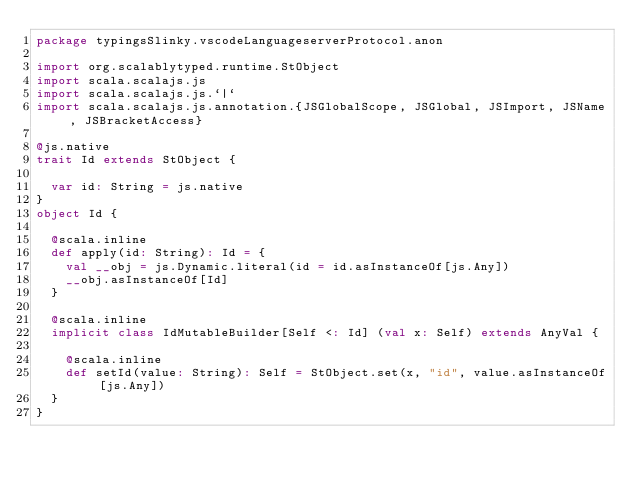<code> <loc_0><loc_0><loc_500><loc_500><_Scala_>package typingsSlinky.vscodeLanguageserverProtocol.anon

import org.scalablytyped.runtime.StObject
import scala.scalajs.js
import scala.scalajs.js.`|`
import scala.scalajs.js.annotation.{JSGlobalScope, JSGlobal, JSImport, JSName, JSBracketAccess}

@js.native
trait Id extends StObject {
  
  var id: String = js.native
}
object Id {
  
  @scala.inline
  def apply(id: String): Id = {
    val __obj = js.Dynamic.literal(id = id.asInstanceOf[js.Any])
    __obj.asInstanceOf[Id]
  }
  
  @scala.inline
  implicit class IdMutableBuilder[Self <: Id] (val x: Self) extends AnyVal {
    
    @scala.inline
    def setId(value: String): Self = StObject.set(x, "id", value.asInstanceOf[js.Any])
  }
}
</code> 